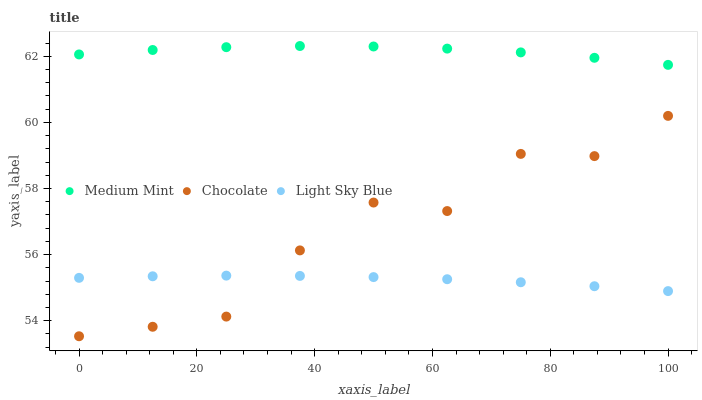Does Light Sky Blue have the minimum area under the curve?
Answer yes or no. Yes. Does Medium Mint have the maximum area under the curve?
Answer yes or no. Yes. Does Chocolate have the minimum area under the curve?
Answer yes or no. No. Does Chocolate have the maximum area under the curve?
Answer yes or no. No. Is Light Sky Blue the smoothest?
Answer yes or no. Yes. Is Chocolate the roughest?
Answer yes or no. Yes. Is Chocolate the smoothest?
Answer yes or no. No. Is Light Sky Blue the roughest?
Answer yes or no. No. Does Chocolate have the lowest value?
Answer yes or no. Yes. Does Light Sky Blue have the lowest value?
Answer yes or no. No. Does Medium Mint have the highest value?
Answer yes or no. Yes. Does Chocolate have the highest value?
Answer yes or no. No. Is Light Sky Blue less than Medium Mint?
Answer yes or no. Yes. Is Medium Mint greater than Light Sky Blue?
Answer yes or no. Yes. Does Light Sky Blue intersect Chocolate?
Answer yes or no. Yes. Is Light Sky Blue less than Chocolate?
Answer yes or no. No. Is Light Sky Blue greater than Chocolate?
Answer yes or no. No. Does Light Sky Blue intersect Medium Mint?
Answer yes or no. No. 